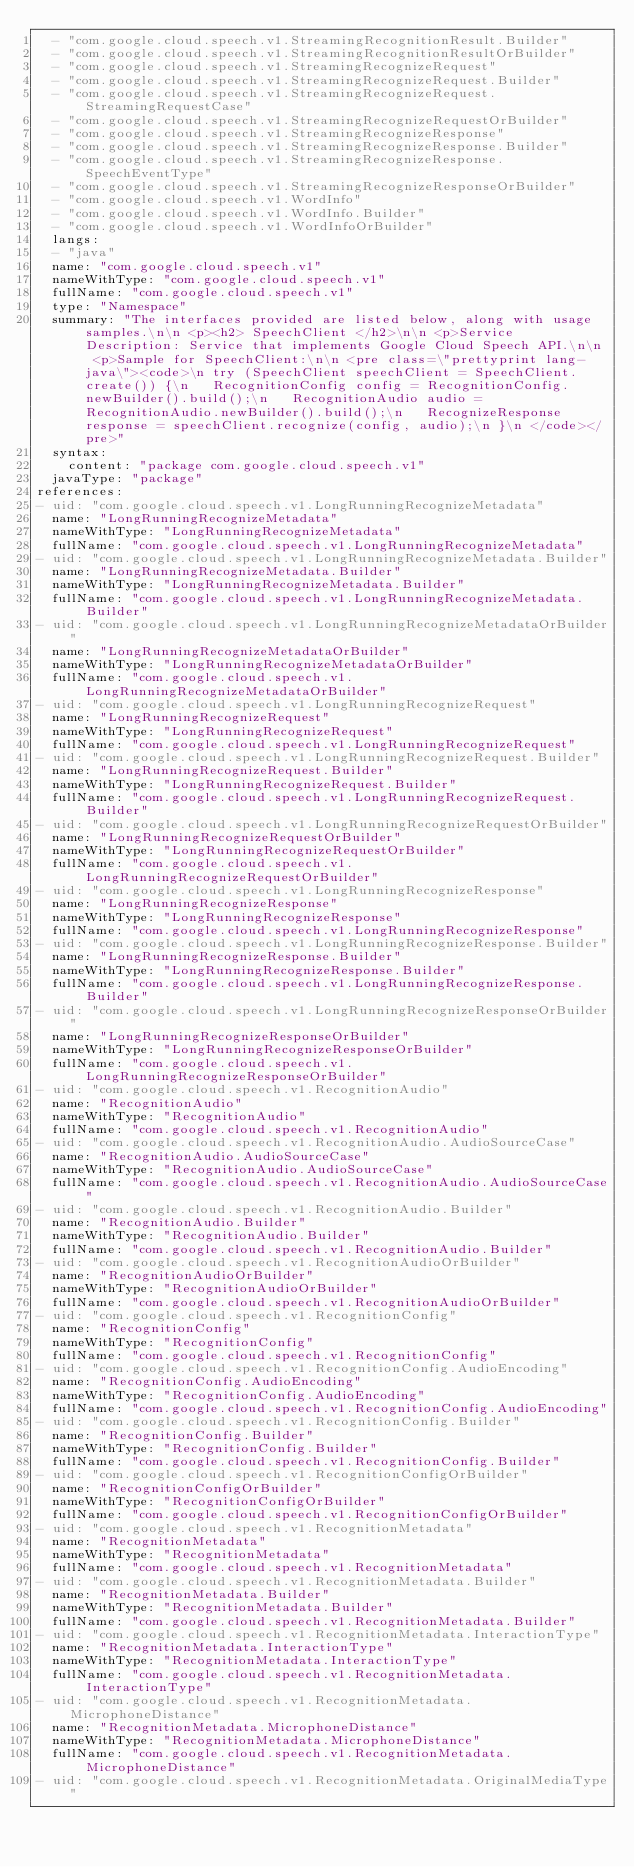Convert code to text. <code><loc_0><loc_0><loc_500><loc_500><_YAML_>  - "com.google.cloud.speech.v1.StreamingRecognitionResult.Builder"
  - "com.google.cloud.speech.v1.StreamingRecognitionResultOrBuilder"
  - "com.google.cloud.speech.v1.StreamingRecognizeRequest"
  - "com.google.cloud.speech.v1.StreamingRecognizeRequest.Builder"
  - "com.google.cloud.speech.v1.StreamingRecognizeRequest.StreamingRequestCase"
  - "com.google.cloud.speech.v1.StreamingRecognizeRequestOrBuilder"
  - "com.google.cloud.speech.v1.StreamingRecognizeResponse"
  - "com.google.cloud.speech.v1.StreamingRecognizeResponse.Builder"
  - "com.google.cloud.speech.v1.StreamingRecognizeResponse.SpeechEventType"
  - "com.google.cloud.speech.v1.StreamingRecognizeResponseOrBuilder"
  - "com.google.cloud.speech.v1.WordInfo"
  - "com.google.cloud.speech.v1.WordInfo.Builder"
  - "com.google.cloud.speech.v1.WordInfoOrBuilder"
  langs:
  - "java"
  name: "com.google.cloud.speech.v1"
  nameWithType: "com.google.cloud.speech.v1"
  fullName: "com.google.cloud.speech.v1"
  type: "Namespace"
  summary: "The interfaces provided are listed below, along with usage samples.\n\n <p><h2> SpeechClient </h2>\n\n <p>Service Description: Service that implements Google Cloud Speech API.\n\n <p>Sample for SpeechClient:\n\n <pre class=\"prettyprint lang-java\"><code>\n try (SpeechClient speechClient = SpeechClient.create()) {\n   RecognitionConfig config = RecognitionConfig.newBuilder().build();\n   RecognitionAudio audio = RecognitionAudio.newBuilder().build();\n   RecognizeResponse response = speechClient.recognize(config, audio);\n }\n </code></pre>"
  syntax:
    content: "package com.google.cloud.speech.v1"
  javaType: "package"
references:
- uid: "com.google.cloud.speech.v1.LongRunningRecognizeMetadata"
  name: "LongRunningRecognizeMetadata"
  nameWithType: "LongRunningRecognizeMetadata"
  fullName: "com.google.cloud.speech.v1.LongRunningRecognizeMetadata"
- uid: "com.google.cloud.speech.v1.LongRunningRecognizeMetadata.Builder"
  name: "LongRunningRecognizeMetadata.Builder"
  nameWithType: "LongRunningRecognizeMetadata.Builder"
  fullName: "com.google.cloud.speech.v1.LongRunningRecognizeMetadata.Builder"
- uid: "com.google.cloud.speech.v1.LongRunningRecognizeMetadataOrBuilder"
  name: "LongRunningRecognizeMetadataOrBuilder"
  nameWithType: "LongRunningRecognizeMetadataOrBuilder"
  fullName: "com.google.cloud.speech.v1.LongRunningRecognizeMetadataOrBuilder"
- uid: "com.google.cloud.speech.v1.LongRunningRecognizeRequest"
  name: "LongRunningRecognizeRequest"
  nameWithType: "LongRunningRecognizeRequest"
  fullName: "com.google.cloud.speech.v1.LongRunningRecognizeRequest"
- uid: "com.google.cloud.speech.v1.LongRunningRecognizeRequest.Builder"
  name: "LongRunningRecognizeRequest.Builder"
  nameWithType: "LongRunningRecognizeRequest.Builder"
  fullName: "com.google.cloud.speech.v1.LongRunningRecognizeRequest.Builder"
- uid: "com.google.cloud.speech.v1.LongRunningRecognizeRequestOrBuilder"
  name: "LongRunningRecognizeRequestOrBuilder"
  nameWithType: "LongRunningRecognizeRequestOrBuilder"
  fullName: "com.google.cloud.speech.v1.LongRunningRecognizeRequestOrBuilder"
- uid: "com.google.cloud.speech.v1.LongRunningRecognizeResponse"
  name: "LongRunningRecognizeResponse"
  nameWithType: "LongRunningRecognizeResponse"
  fullName: "com.google.cloud.speech.v1.LongRunningRecognizeResponse"
- uid: "com.google.cloud.speech.v1.LongRunningRecognizeResponse.Builder"
  name: "LongRunningRecognizeResponse.Builder"
  nameWithType: "LongRunningRecognizeResponse.Builder"
  fullName: "com.google.cloud.speech.v1.LongRunningRecognizeResponse.Builder"
- uid: "com.google.cloud.speech.v1.LongRunningRecognizeResponseOrBuilder"
  name: "LongRunningRecognizeResponseOrBuilder"
  nameWithType: "LongRunningRecognizeResponseOrBuilder"
  fullName: "com.google.cloud.speech.v1.LongRunningRecognizeResponseOrBuilder"
- uid: "com.google.cloud.speech.v1.RecognitionAudio"
  name: "RecognitionAudio"
  nameWithType: "RecognitionAudio"
  fullName: "com.google.cloud.speech.v1.RecognitionAudio"
- uid: "com.google.cloud.speech.v1.RecognitionAudio.AudioSourceCase"
  name: "RecognitionAudio.AudioSourceCase"
  nameWithType: "RecognitionAudio.AudioSourceCase"
  fullName: "com.google.cloud.speech.v1.RecognitionAudio.AudioSourceCase"
- uid: "com.google.cloud.speech.v1.RecognitionAudio.Builder"
  name: "RecognitionAudio.Builder"
  nameWithType: "RecognitionAudio.Builder"
  fullName: "com.google.cloud.speech.v1.RecognitionAudio.Builder"
- uid: "com.google.cloud.speech.v1.RecognitionAudioOrBuilder"
  name: "RecognitionAudioOrBuilder"
  nameWithType: "RecognitionAudioOrBuilder"
  fullName: "com.google.cloud.speech.v1.RecognitionAudioOrBuilder"
- uid: "com.google.cloud.speech.v1.RecognitionConfig"
  name: "RecognitionConfig"
  nameWithType: "RecognitionConfig"
  fullName: "com.google.cloud.speech.v1.RecognitionConfig"
- uid: "com.google.cloud.speech.v1.RecognitionConfig.AudioEncoding"
  name: "RecognitionConfig.AudioEncoding"
  nameWithType: "RecognitionConfig.AudioEncoding"
  fullName: "com.google.cloud.speech.v1.RecognitionConfig.AudioEncoding"
- uid: "com.google.cloud.speech.v1.RecognitionConfig.Builder"
  name: "RecognitionConfig.Builder"
  nameWithType: "RecognitionConfig.Builder"
  fullName: "com.google.cloud.speech.v1.RecognitionConfig.Builder"
- uid: "com.google.cloud.speech.v1.RecognitionConfigOrBuilder"
  name: "RecognitionConfigOrBuilder"
  nameWithType: "RecognitionConfigOrBuilder"
  fullName: "com.google.cloud.speech.v1.RecognitionConfigOrBuilder"
- uid: "com.google.cloud.speech.v1.RecognitionMetadata"
  name: "RecognitionMetadata"
  nameWithType: "RecognitionMetadata"
  fullName: "com.google.cloud.speech.v1.RecognitionMetadata"
- uid: "com.google.cloud.speech.v1.RecognitionMetadata.Builder"
  name: "RecognitionMetadata.Builder"
  nameWithType: "RecognitionMetadata.Builder"
  fullName: "com.google.cloud.speech.v1.RecognitionMetadata.Builder"
- uid: "com.google.cloud.speech.v1.RecognitionMetadata.InteractionType"
  name: "RecognitionMetadata.InteractionType"
  nameWithType: "RecognitionMetadata.InteractionType"
  fullName: "com.google.cloud.speech.v1.RecognitionMetadata.InteractionType"
- uid: "com.google.cloud.speech.v1.RecognitionMetadata.MicrophoneDistance"
  name: "RecognitionMetadata.MicrophoneDistance"
  nameWithType: "RecognitionMetadata.MicrophoneDistance"
  fullName: "com.google.cloud.speech.v1.RecognitionMetadata.MicrophoneDistance"
- uid: "com.google.cloud.speech.v1.RecognitionMetadata.OriginalMediaType"</code> 